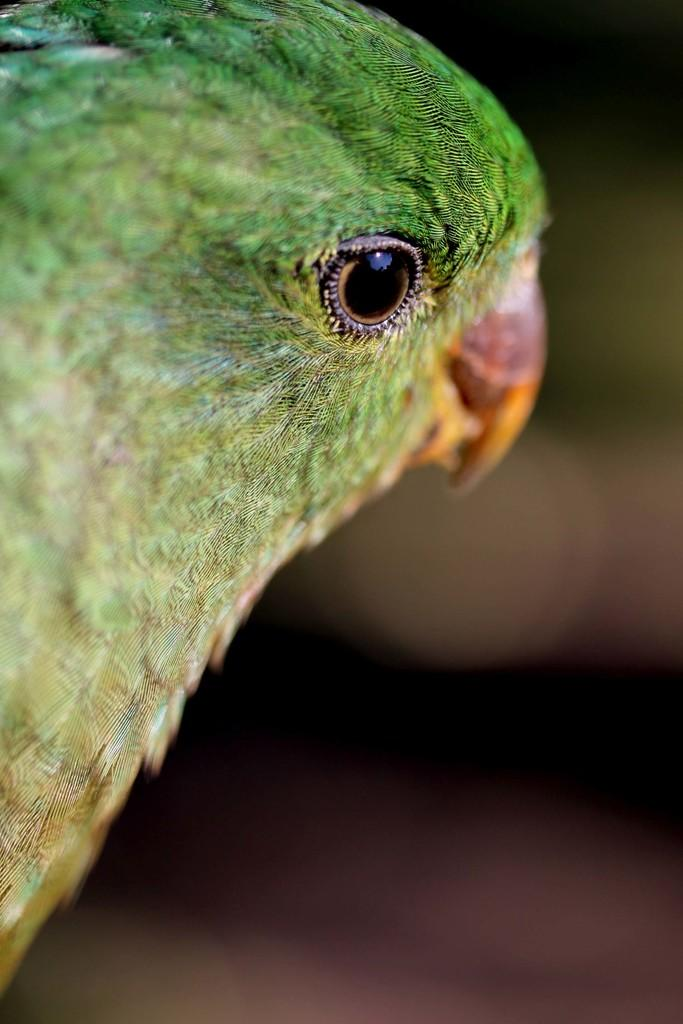What type of animal is the main subject of the image? The main subject of the image is a parrot. What part of the parrot is the focus of the image? The image is a zoom-in picture of the parrot's face. What type of oven can be seen in the background of the image? There is no oven present in the image; it is a close-up picture of a parrot's face. 